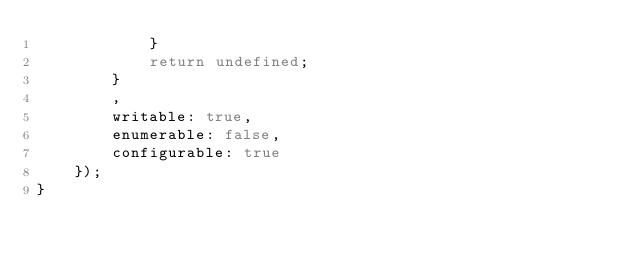<code> <loc_0><loc_0><loc_500><loc_500><_JavaScript_>            }
            return undefined;
        }
        ,
        writable: true,
        enumerable: false,
        configurable: true
    });
}
</code> 